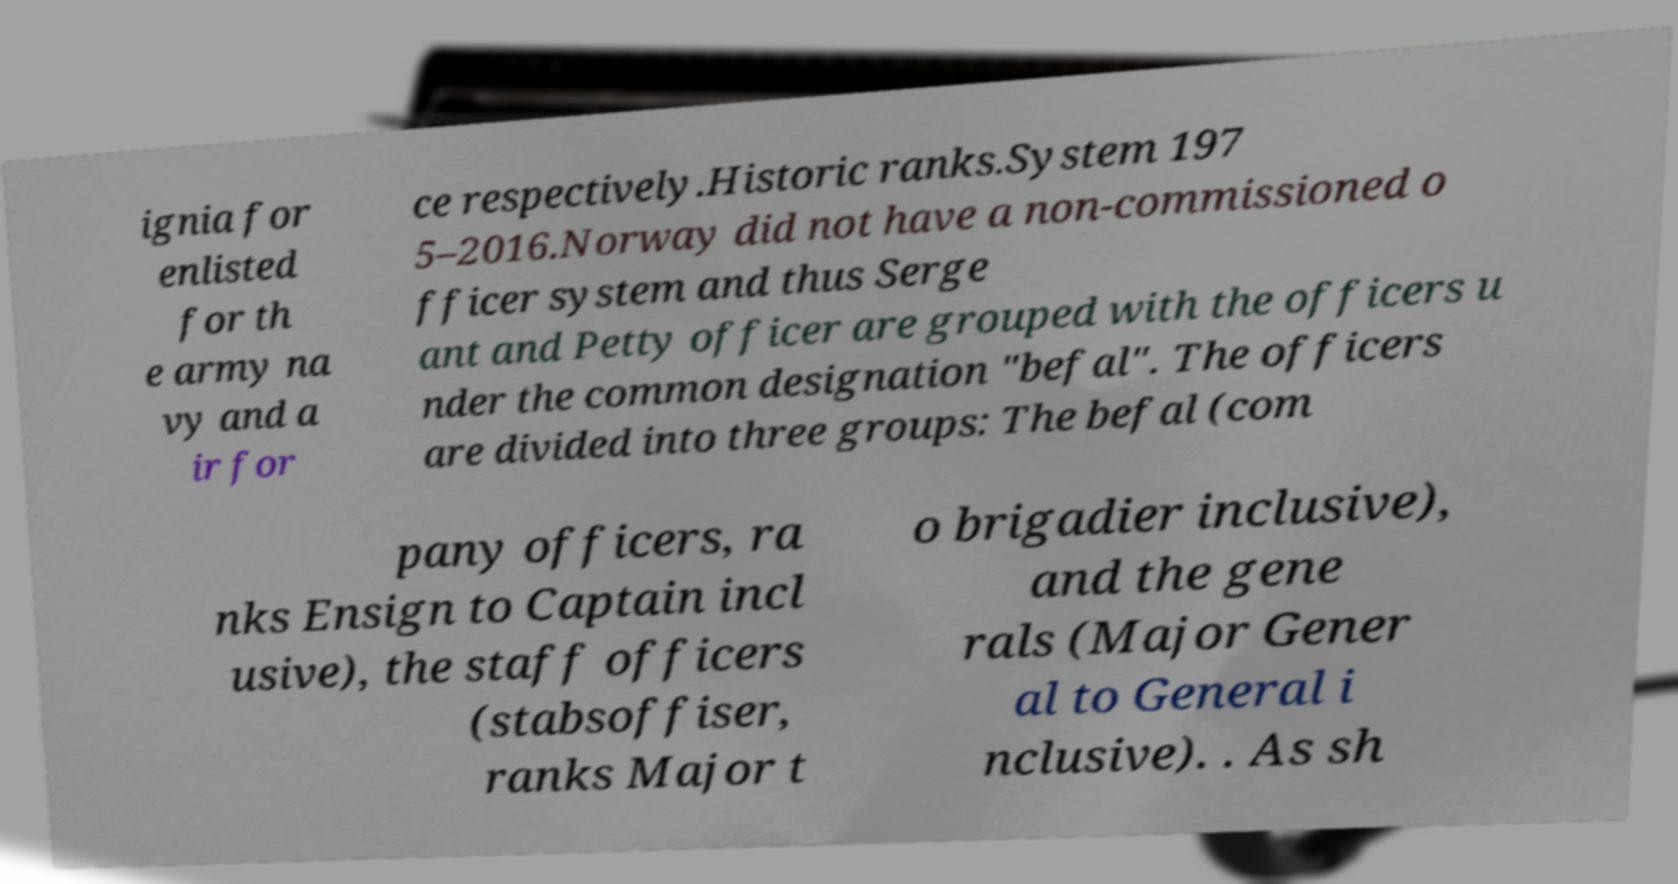I need the written content from this picture converted into text. Can you do that? ignia for enlisted for th e army na vy and a ir for ce respectively.Historic ranks.System 197 5–2016.Norway did not have a non-commissioned o fficer system and thus Serge ant and Petty officer are grouped with the officers u nder the common designation "befal". The officers are divided into three groups: The befal (com pany officers, ra nks Ensign to Captain incl usive), the staff officers (stabsoffiser, ranks Major t o brigadier inclusive), and the gene rals (Major Gener al to General i nclusive). . As sh 